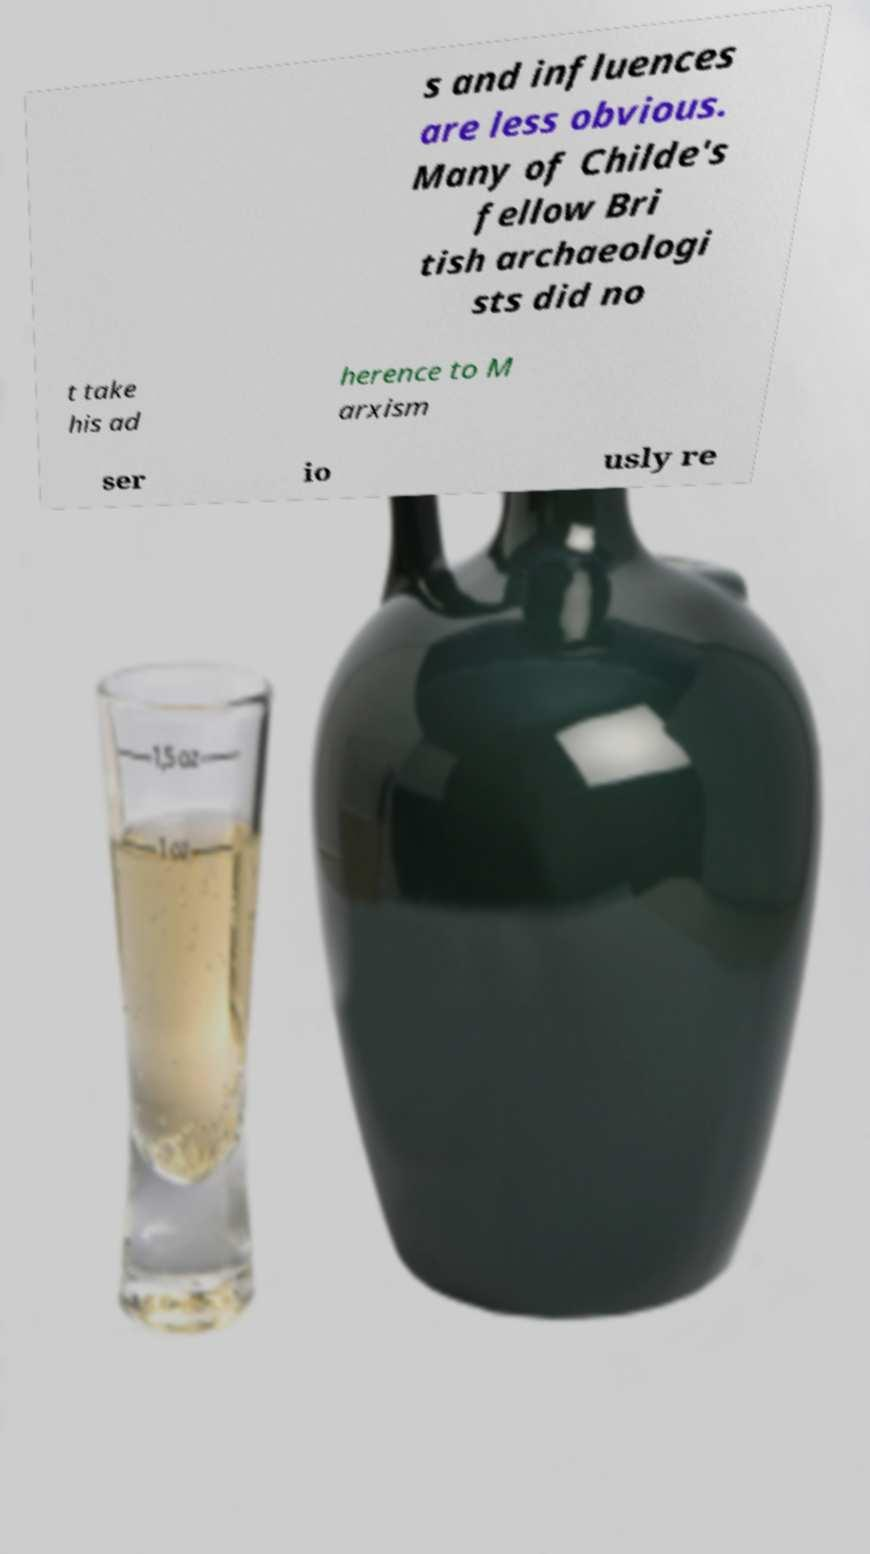For documentation purposes, I need the text within this image transcribed. Could you provide that? s and influences are less obvious. Many of Childe's fellow Bri tish archaeologi sts did no t take his ad herence to M arxism ser io usly re 